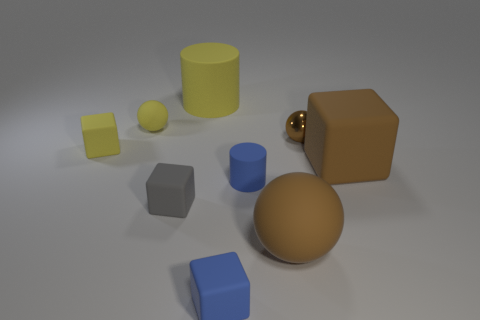Do the big matte block and the tiny metal object have the same color?
Offer a very short reply. Yes. What is the material of the other large ball that is the same color as the shiny ball?
Your answer should be very brief. Rubber. What is the material of the tiny yellow object on the right side of the tiny rubber block behind the big brown thing that is to the right of the big matte sphere?
Your response must be concise. Rubber. There is a matte cube that is the same color as the tiny matte ball; what size is it?
Ensure brevity in your answer.  Small. What material is the tiny brown object?
Ensure brevity in your answer.  Metal. Are the gray cube and the brown sphere that is to the right of the large rubber sphere made of the same material?
Give a very brief answer. No. The matte sphere behind the matte cylinder to the right of the yellow matte cylinder is what color?
Offer a very short reply. Yellow. What is the size of the rubber object that is both on the right side of the small cylinder and in front of the blue cylinder?
Provide a succinct answer. Large. What number of other things are there of the same shape as the small metal object?
Keep it short and to the point. 2. There is a small brown thing; does it have the same shape as the big brown matte object that is in front of the gray thing?
Provide a succinct answer. Yes. 